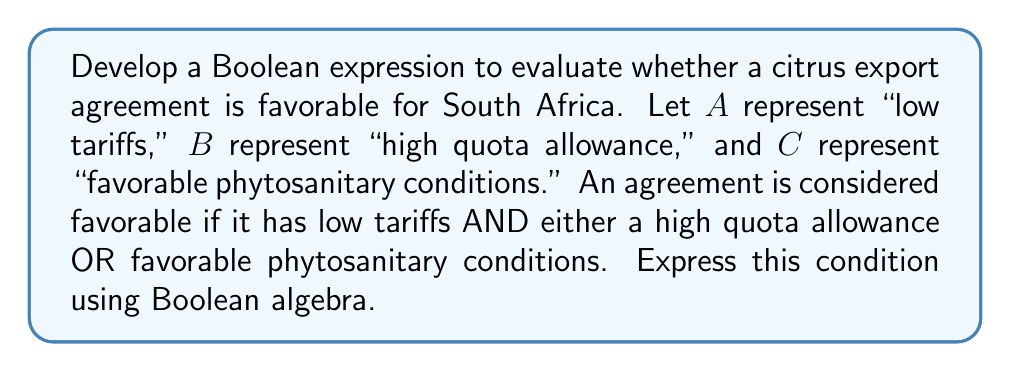Help me with this question. Let's approach this step-by-step:

1) We need to combine the given conditions using Boolean operators:
   - Low tariffs (A) is a must-have condition
   - Either high quota allowance (B) OR favorable phytosanitary conditions (C) is required

2) We can express "either B or C" as $B + C$ in Boolean algebra, where '+' represents the OR operation

3) We then need to AND this with the condition A, which is represented by multiplication in Boolean algebra

4) Therefore, the Boolean expression becomes:

   $$ A \cdot (B + C) $$

5) This can be read as: "A AND (B OR C)"

6) In Boolean algebra, this expression means that the result will be true (1) if:
   - A is true (1) AND
   - Either B is true (1) OR C is true (1) (or both)

7) This accurately represents our conditions for a favorable citrus export agreement
Answer: $A \cdot (B + C)$ 